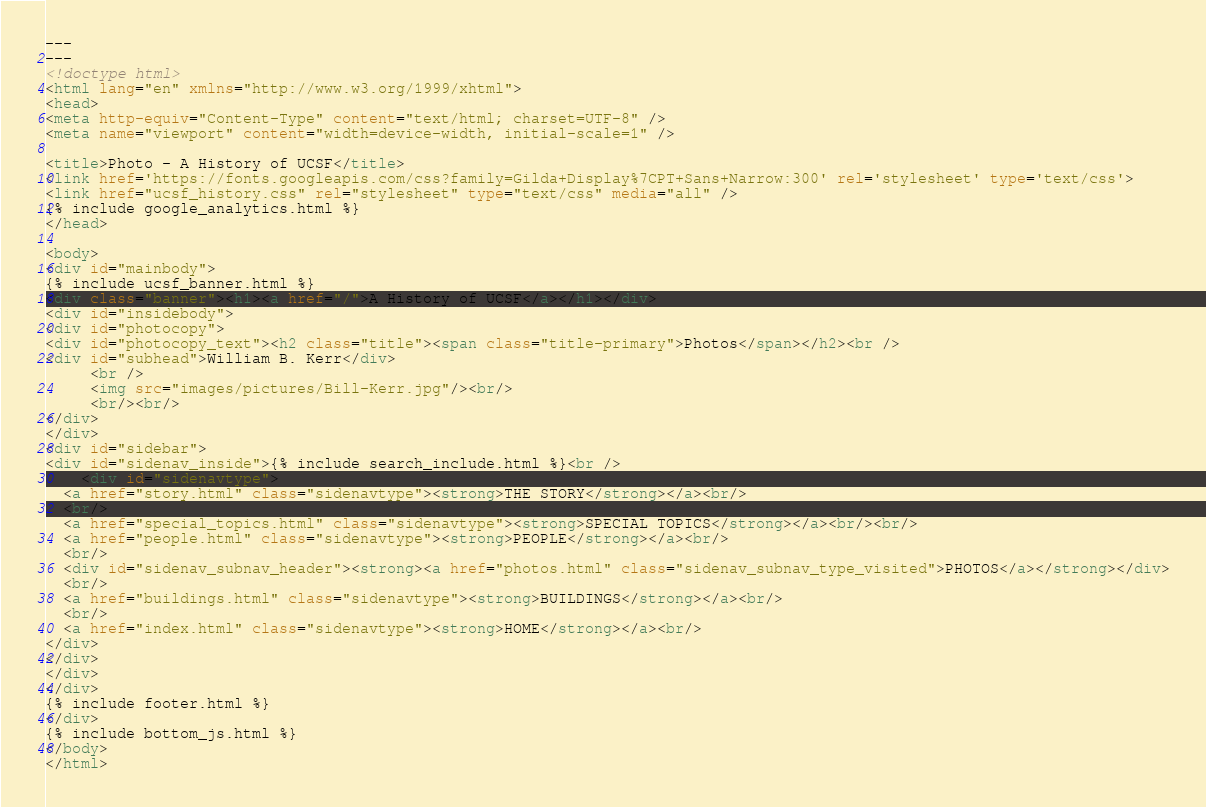Convert code to text. <code><loc_0><loc_0><loc_500><loc_500><_HTML_>---
---
<!doctype html>
<html lang="en" xmlns="http://www.w3.org/1999/xhtml">
<head>
<meta http-equiv="Content-Type" content="text/html; charset=UTF-8" />
<meta name="viewport" content="width=device-width, initial-scale=1" />

<title>Photo - A History of UCSF</title>
<link href='https://fonts.googleapis.com/css?family=Gilda+Display%7CPT+Sans+Narrow:300' rel='stylesheet' type='text/css'>
<link href="ucsf_history.css" rel="stylesheet" type="text/css" media="all" />
{% include google_analytics.html %}
</head>

<body>
<div id="mainbody">
{% include ucsf_banner.html %}
<div class="banner"><h1><a href="/">A History of UCSF</a></h1></div>
<div id="insidebody">
<div id="photocopy">
<div id="photocopy_text"><h2 class="title"><span class="title-primary">Photos</span></h2><br />
<div id="subhead">William B. Kerr</div>
     <br />
     <img src="images/pictures/Bill-Kerr.jpg"/><br/>
     <br/><br/>
</div>
</div>
<div id="sidebar">
<div id="sidenav_inside">{% include search_include.html %}<br />
    <div id="sidenavtype">
  <a href="story.html" class="sidenavtype"><strong>THE STORY</strong></a><br/>
  <br/>
  <a href="special_topics.html" class="sidenavtype"><strong>SPECIAL TOPICS</strong></a><br/><br/>
  <a href="people.html" class="sidenavtype"><strong>PEOPLE</strong></a><br/>
  <br/>
  <div id="sidenav_subnav_header"><strong><a href="photos.html" class="sidenav_subnav_type_visited">PHOTOS</a></strong></div>
  <br/>
  <a href="buildings.html" class="sidenavtype"><strong>BUILDINGS</strong></a><br/>
  <br/>
  <a href="index.html" class="sidenavtype"><strong>HOME</strong></a><br/>
</div>
</div>
</div>
</div>
{% include footer.html %}
</div>
{% include bottom_js.html %}
</body>
</html>
</code> 